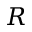Convert formula to latex. <formula><loc_0><loc_0><loc_500><loc_500>R</formula> 